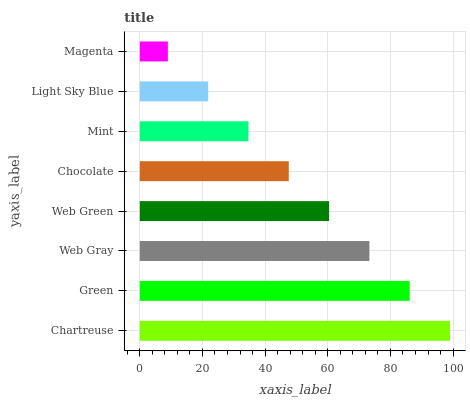Is Magenta the minimum?
Answer yes or no. Yes. Is Chartreuse the maximum?
Answer yes or no. Yes. Is Green the minimum?
Answer yes or no. No. Is Green the maximum?
Answer yes or no. No. Is Chartreuse greater than Green?
Answer yes or no. Yes. Is Green less than Chartreuse?
Answer yes or no. Yes. Is Green greater than Chartreuse?
Answer yes or no. No. Is Chartreuse less than Green?
Answer yes or no. No. Is Web Green the high median?
Answer yes or no. Yes. Is Chocolate the low median?
Answer yes or no. Yes. Is Mint the high median?
Answer yes or no. No. Is Light Sky Blue the low median?
Answer yes or no. No. 